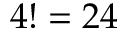Convert formula to latex. <formula><loc_0><loc_0><loc_500><loc_500>4 ! = 2 4</formula> 